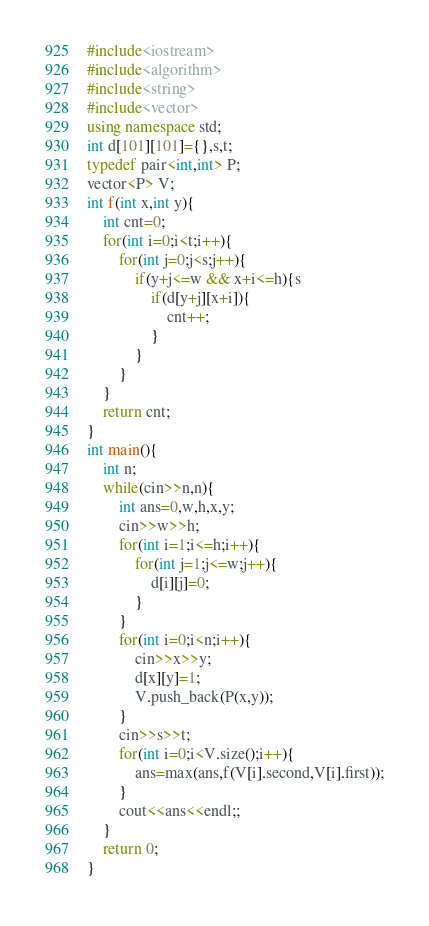<code> <loc_0><loc_0><loc_500><loc_500><_C++_>#include<iostream>
#include<algorithm>
#include<string>
#include<vector>
using namespace std;
int d[101][101]={},s,t;
typedef pair<int,int> P;
vector<P> V;
int f(int x,int y){
	int cnt=0;
	for(int i=0;i<t;i++){
		for(int j=0;j<s;j++){
			if(y+j<=w && x+i<=h){s
				if(d[y+j][x+i]){
					cnt++;
				}
			}
		}
	}
	return cnt;
}
int main(){
	int n;
	while(cin>>n,n){
		int ans=0,w,h,x,y;
		cin>>w>>h;
		for(int i=1;i<=h;i++){
			for(int j=1;j<=w;j++){
				d[i][j]=0;
			}
		}
		for(int i=0;i<n;i++){
			cin>>x>>y;
			d[x][y]=1;
			V.push_back(P(x,y));
		}
		cin>>s>>t;
		for(int i=0;i<V.size();i++){
			ans=max(ans,f(V[i].second,V[i].first));
		}
		cout<<ans<<endl;;
	}
	return 0;
}</code> 